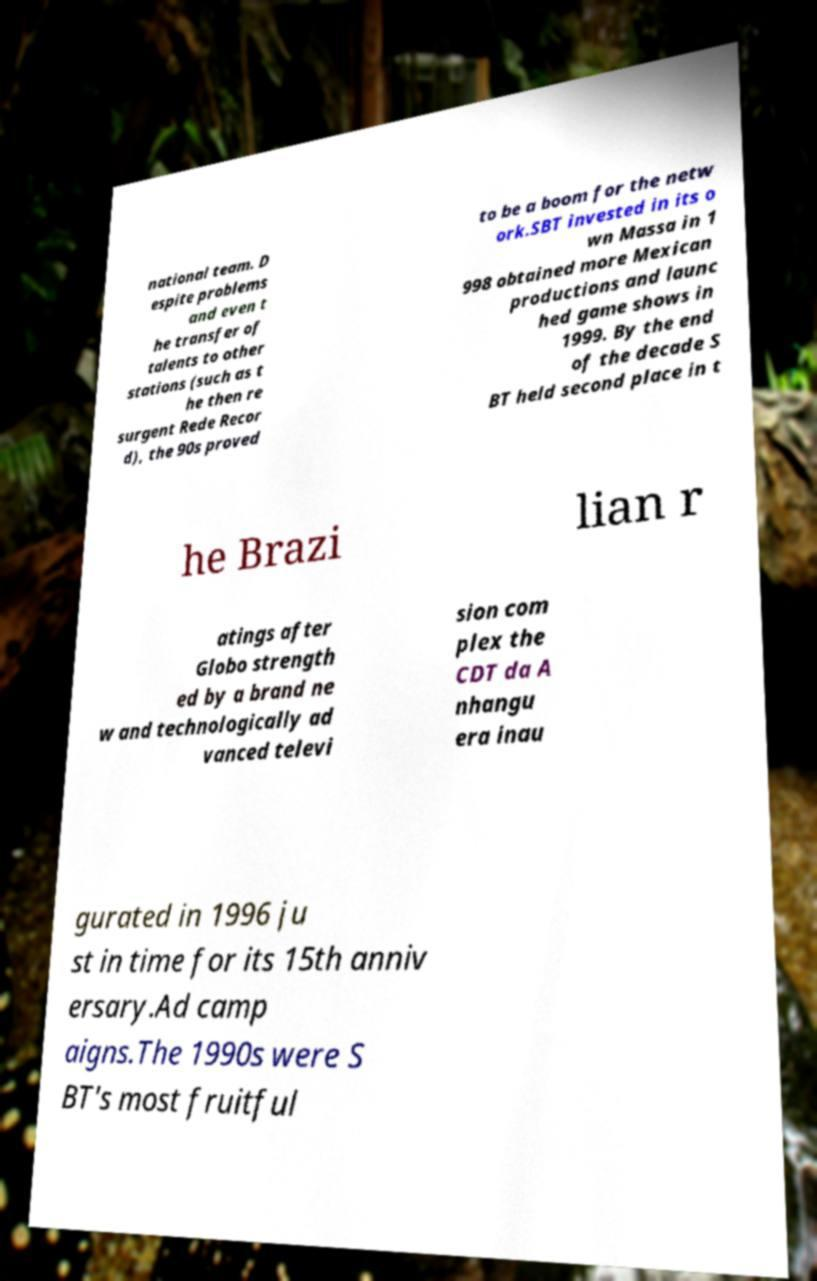Please identify and transcribe the text found in this image. national team. D espite problems and even t he transfer of talents to other stations (such as t he then re surgent Rede Recor d), the 90s proved to be a boom for the netw ork.SBT invested in its o wn Massa in 1 998 obtained more Mexican productions and launc hed game shows in 1999. By the end of the decade S BT held second place in t he Brazi lian r atings after Globo strength ed by a brand ne w and technologically ad vanced televi sion com plex the CDT da A nhangu era inau gurated in 1996 ju st in time for its 15th anniv ersary.Ad camp aigns.The 1990s were S BT's most fruitful 